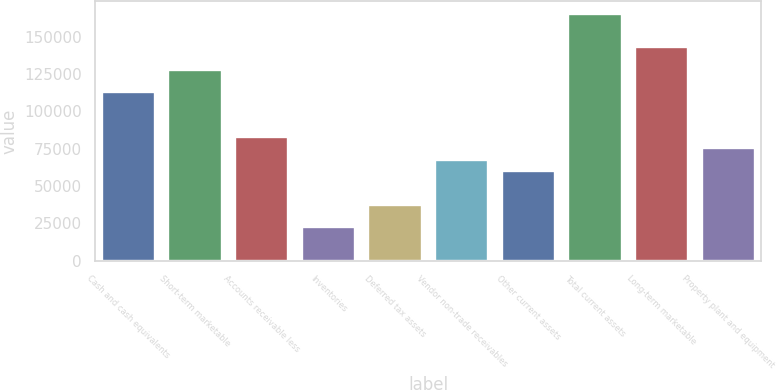Convert chart. <chart><loc_0><loc_0><loc_500><loc_500><bar_chart><fcel>Cash and cash equivalents<fcel>Short-term marketable<fcel>Accounts receivable less<fcel>Inventories<fcel>Deferred tax assets<fcel>Vendor non-trade receivables<fcel>Other current assets<fcel>Total current assets<fcel>Long-term marketable<fcel>Property plant and equipment<nl><fcel>112752<fcel>127779<fcel>82696.7<fcel>22587.1<fcel>37614.5<fcel>67669.3<fcel>60155.6<fcel>165347<fcel>142806<fcel>75183<nl></chart> 